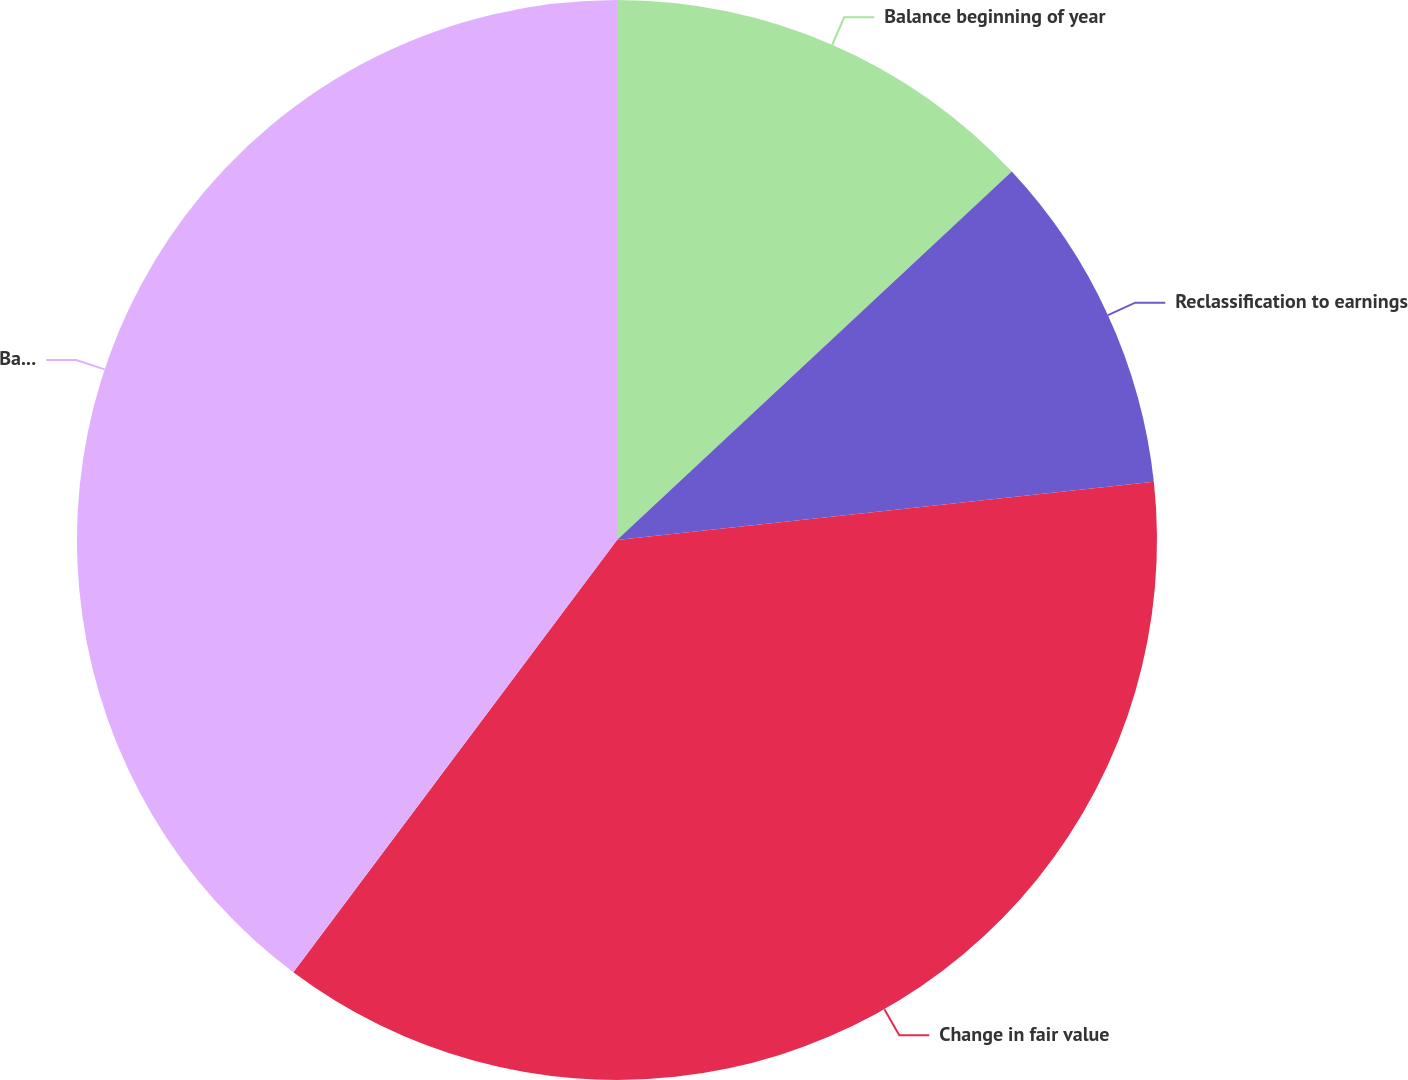<chart> <loc_0><loc_0><loc_500><loc_500><pie_chart><fcel>Balance beginning of year<fcel>Reclassification to earnings<fcel>Change in fair value<fcel>Balance December 31<nl><fcel>13.05%<fcel>10.23%<fcel>36.95%<fcel>39.77%<nl></chart> 